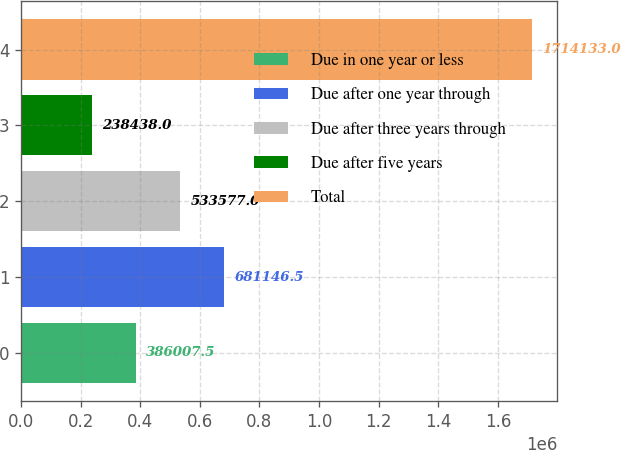Convert chart. <chart><loc_0><loc_0><loc_500><loc_500><bar_chart><fcel>Due in one year or less<fcel>Due after one year through<fcel>Due after three years through<fcel>Due after five years<fcel>Total<nl><fcel>386008<fcel>681146<fcel>533577<fcel>238438<fcel>1.71413e+06<nl></chart> 